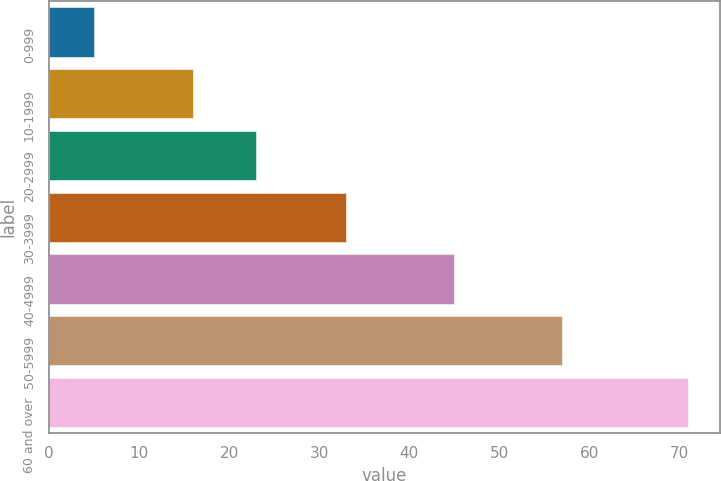Convert chart to OTSL. <chart><loc_0><loc_0><loc_500><loc_500><bar_chart><fcel>0-999<fcel>10-1999<fcel>20-2999<fcel>30-3999<fcel>40-4999<fcel>50-5999<fcel>60 and over<nl><fcel>5<fcel>16<fcel>23<fcel>33<fcel>45<fcel>57<fcel>71<nl></chart> 